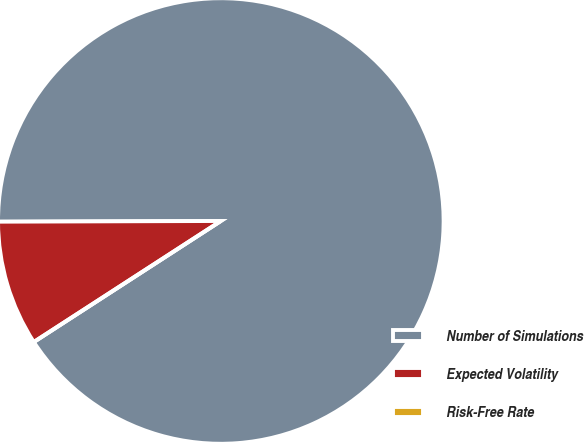<chart> <loc_0><loc_0><loc_500><loc_500><pie_chart><fcel>Number of Simulations<fcel>Expected Volatility<fcel>Risk-Free Rate<nl><fcel>90.91%<fcel>9.09%<fcel>0.0%<nl></chart> 